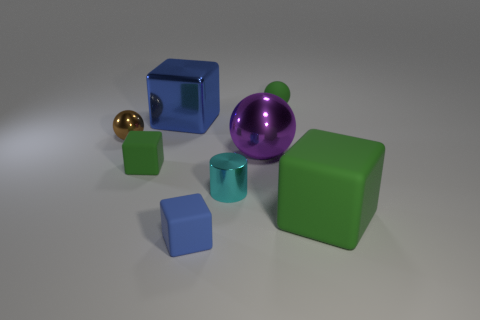The matte thing that is on the right side of the cyan metallic cylinder and behind the big green block is what color?
Offer a very short reply. Green. How many big things are green shiny blocks or objects?
Your answer should be compact. 3. The brown thing that is the same shape as the large purple metal thing is what size?
Give a very brief answer. Small. What shape is the large blue object?
Keep it short and to the point. Cube. Do the big purple ball and the tiny brown object that is behind the big purple metal sphere have the same material?
Your response must be concise. Yes. What number of shiny objects are either tiny green cylinders or green spheres?
Give a very brief answer. 0. What is the size of the rubber block left of the small blue object?
Offer a very short reply. Small. What is the size of the brown object that is the same material as the purple sphere?
Offer a terse response. Small. How many big shiny blocks are the same color as the metal cylinder?
Make the answer very short. 0. Is there a big purple rubber thing?
Provide a short and direct response. No. 